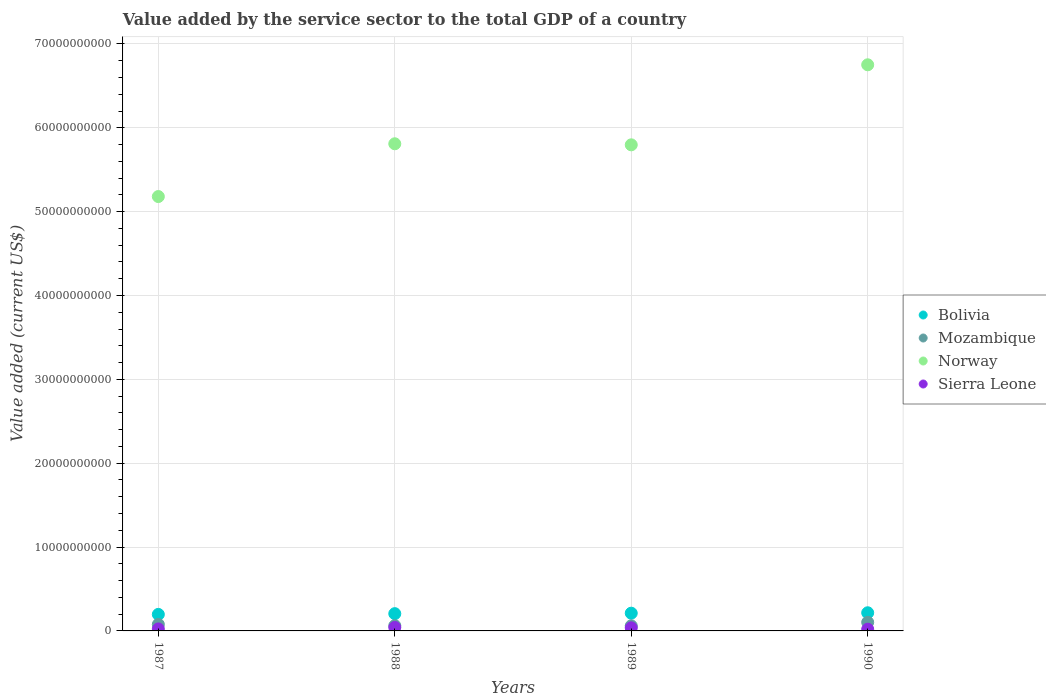Is the number of dotlines equal to the number of legend labels?
Make the answer very short. Yes. What is the value added by the service sector to the total GDP in Norway in 1989?
Make the answer very short. 5.80e+1. Across all years, what is the maximum value added by the service sector to the total GDP in Mozambique?
Your answer should be compact. 1.03e+09. Across all years, what is the minimum value added by the service sector to the total GDP in Sierra Leone?
Make the answer very short. 2.07e+08. What is the total value added by the service sector to the total GDP in Norway in the graph?
Make the answer very short. 2.35e+11. What is the difference between the value added by the service sector to the total GDP in Mozambique in 1987 and that in 1988?
Provide a short and direct response. 1.50e+08. What is the difference between the value added by the service sector to the total GDP in Mozambique in 1989 and the value added by the service sector to the total GDP in Norway in 1990?
Your response must be concise. -6.69e+1. What is the average value added by the service sector to the total GDP in Sierra Leone per year?
Your answer should be compact. 3.08e+08. In the year 1988, what is the difference between the value added by the service sector to the total GDP in Mozambique and value added by the service sector to the total GDP in Bolivia?
Your response must be concise. -1.43e+09. What is the ratio of the value added by the service sector to the total GDP in Sierra Leone in 1987 to that in 1989?
Your answer should be compact. 0.64. Is the value added by the service sector to the total GDP in Norway in 1987 less than that in 1989?
Make the answer very short. Yes. Is the difference between the value added by the service sector to the total GDP in Mozambique in 1987 and 1989 greater than the difference between the value added by the service sector to the total GDP in Bolivia in 1987 and 1989?
Make the answer very short. Yes. What is the difference between the highest and the second highest value added by the service sector to the total GDP in Bolivia?
Provide a short and direct response. 4.98e+07. What is the difference between the highest and the lowest value added by the service sector to the total GDP in Bolivia?
Your response must be concise. 1.94e+08. In how many years, is the value added by the service sector to the total GDP in Norway greater than the average value added by the service sector to the total GDP in Norway taken over all years?
Keep it short and to the point. 1. Is the sum of the value added by the service sector to the total GDP in Norway in 1987 and 1989 greater than the maximum value added by the service sector to the total GDP in Bolivia across all years?
Offer a very short reply. Yes. Is it the case that in every year, the sum of the value added by the service sector to the total GDP in Sierra Leone and value added by the service sector to the total GDP in Mozambique  is greater than the sum of value added by the service sector to the total GDP in Bolivia and value added by the service sector to the total GDP in Norway?
Give a very brief answer. No. Is it the case that in every year, the sum of the value added by the service sector to the total GDP in Bolivia and value added by the service sector to the total GDP in Mozambique  is greater than the value added by the service sector to the total GDP in Sierra Leone?
Provide a short and direct response. Yes. Is the value added by the service sector to the total GDP in Sierra Leone strictly greater than the value added by the service sector to the total GDP in Bolivia over the years?
Provide a short and direct response. No. How many dotlines are there?
Your answer should be very brief. 4. How many years are there in the graph?
Provide a succinct answer. 4. What is the difference between two consecutive major ticks on the Y-axis?
Make the answer very short. 1.00e+1. Are the values on the major ticks of Y-axis written in scientific E-notation?
Keep it short and to the point. No. Does the graph contain any zero values?
Provide a short and direct response. No. Where does the legend appear in the graph?
Provide a succinct answer. Center right. How many legend labels are there?
Give a very brief answer. 4. What is the title of the graph?
Your response must be concise. Value added by the service sector to the total GDP of a country. What is the label or title of the Y-axis?
Provide a succinct answer. Value added (current US$). What is the Value added (current US$) of Bolivia in 1987?
Ensure brevity in your answer.  1.97e+09. What is the Value added (current US$) in Mozambique in 1987?
Ensure brevity in your answer.  7.77e+08. What is the Value added (current US$) of Norway in 1987?
Provide a short and direct response. 5.18e+1. What is the Value added (current US$) of Sierra Leone in 1987?
Your answer should be very brief. 2.38e+08. What is the Value added (current US$) in Bolivia in 1988?
Give a very brief answer. 2.06e+09. What is the Value added (current US$) of Mozambique in 1988?
Offer a very short reply. 6.27e+08. What is the Value added (current US$) in Norway in 1988?
Make the answer very short. 5.81e+1. What is the Value added (current US$) in Sierra Leone in 1988?
Keep it short and to the point. 4.17e+08. What is the Value added (current US$) of Bolivia in 1989?
Provide a succinct answer. 2.12e+09. What is the Value added (current US$) in Mozambique in 1989?
Ensure brevity in your answer.  6.05e+08. What is the Value added (current US$) in Norway in 1989?
Offer a very short reply. 5.80e+1. What is the Value added (current US$) of Sierra Leone in 1989?
Ensure brevity in your answer.  3.71e+08. What is the Value added (current US$) of Bolivia in 1990?
Your response must be concise. 2.16e+09. What is the Value added (current US$) of Mozambique in 1990?
Provide a succinct answer. 1.03e+09. What is the Value added (current US$) in Norway in 1990?
Offer a terse response. 6.75e+1. What is the Value added (current US$) of Sierra Leone in 1990?
Your answer should be very brief. 2.07e+08. Across all years, what is the maximum Value added (current US$) in Bolivia?
Provide a succinct answer. 2.16e+09. Across all years, what is the maximum Value added (current US$) of Mozambique?
Offer a very short reply. 1.03e+09. Across all years, what is the maximum Value added (current US$) in Norway?
Your answer should be compact. 6.75e+1. Across all years, what is the maximum Value added (current US$) in Sierra Leone?
Offer a very short reply. 4.17e+08. Across all years, what is the minimum Value added (current US$) in Bolivia?
Provide a short and direct response. 1.97e+09. Across all years, what is the minimum Value added (current US$) of Mozambique?
Ensure brevity in your answer.  6.05e+08. Across all years, what is the minimum Value added (current US$) in Norway?
Keep it short and to the point. 5.18e+1. Across all years, what is the minimum Value added (current US$) of Sierra Leone?
Your answer should be compact. 2.07e+08. What is the total Value added (current US$) of Bolivia in the graph?
Your answer should be very brief. 8.31e+09. What is the total Value added (current US$) in Mozambique in the graph?
Keep it short and to the point. 3.03e+09. What is the total Value added (current US$) of Norway in the graph?
Ensure brevity in your answer.  2.35e+11. What is the total Value added (current US$) in Sierra Leone in the graph?
Make the answer very short. 1.23e+09. What is the difference between the Value added (current US$) in Bolivia in 1987 and that in 1988?
Give a very brief answer. -8.81e+07. What is the difference between the Value added (current US$) in Mozambique in 1987 and that in 1988?
Offer a terse response. 1.50e+08. What is the difference between the Value added (current US$) in Norway in 1987 and that in 1988?
Provide a short and direct response. -6.29e+09. What is the difference between the Value added (current US$) in Sierra Leone in 1987 and that in 1988?
Offer a very short reply. -1.79e+08. What is the difference between the Value added (current US$) in Bolivia in 1987 and that in 1989?
Make the answer very short. -1.44e+08. What is the difference between the Value added (current US$) of Mozambique in 1987 and that in 1989?
Ensure brevity in your answer.  1.72e+08. What is the difference between the Value added (current US$) in Norway in 1987 and that in 1989?
Provide a short and direct response. -6.17e+09. What is the difference between the Value added (current US$) in Sierra Leone in 1987 and that in 1989?
Offer a terse response. -1.32e+08. What is the difference between the Value added (current US$) of Bolivia in 1987 and that in 1990?
Ensure brevity in your answer.  -1.94e+08. What is the difference between the Value added (current US$) of Mozambique in 1987 and that in 1990?
Offer a terse response. -2.50e+08. What is the difference between the Value added (current US$) in Norway in 1987 and that in 1990?
Offer a very short reply. -1.57e+1. What is the difference between the Value added (current US$) in Sierra Leone in 1987 and that in 1990?
Offer a terse response. 3.17e+07. What is the difference between the Value added (current US$) of Bolivia in 1988 and that in 1989?
Offer a very short reply. -5.59e+07. What is the difference between the Value added (current US$) in Mozambique in 1988 and that in 1989?
Keep it short and to the point. 2.19e+07. What is the difference between the Value added (current US$) of Norway in 1988 and that in 1989?
Your response must be concise. 1.26e+08. What is the difference between the Value added (current US$) of Sierra Leone in 1988 and that in 1989?
Your answer should be compact. 4.65e+07. What is the difference between the Value added (current US$) in Bolivia in 1988 and that in 1990?
Your answer should be compact. -1.06e+08. What is the difference between the Value added (current US$) of Mozambique in 1988 and that in 1990?
Give a very brief answer. -4.00e+08. What is the difference between the Value added (current US$) of Norway in 1988 and that in 1990?
Provide a short and direct response. -9.42e+09. What is the difference between the Value added (current US$) in Sierra Leone in 1988 and that in 1990?
Provide a short and direct response. 2.11e+08. What is the difference between the Value added (current US$) of Bolivia in 1989 and that in 1990?
Provide a succinct answer. -4.98e+07. What is the difference between the Value added (current US$) of Mozambique in 1989 and that in 1990?
Provide a short and direct response. -4.22e+08. What is the difference between the Value added (current US$) in Norway in 1989 and that in 1990?
Provide a short and direct response. -9.54e+09. What is the difference between the Value added (current US$) of Sierra Leone in 1989 and that in 1990?
Make the answer very short. 1.64e+08. What is the difference between the Value added (current US$) of Bolivia in 1987 and the Value added (current US$) of Mozambique in 1988?
Your response must be concise. 1.34e+09. What is the difference between the Value added (current US$) of Bolivia in 1987 and the Value added (current US$) of Norway in 1988?
Provide a short and direct response. -5.61e+1. What is the difference between the Value added (current US$) of Bolivia in 1987 and the Value added (current US$) of Sierra Leone in 1988?
Offer a terse response. 1.55e+09. What is the difference between the Value added (current US$) in Mozambique in 1987 and the Value added (current US$) in Norway in 1988?
Offer a very short reply. -5.73e+1. What is the difference between the Value added (current US$) of Mozambique in 1987 and the Value added (current US$) of Sierra Leone in 1988?
Offer a very short reply. 3.59e+08. What is the difference between the Value added (current US$) of Norway in 1987 and the Value added (current US$) of Sierra Leone in 1988?
Give a very brief answer. 5.14e+1. What is the difference between the Value added (current US$) of Bolivia in 1987 and the Value added (current US$) of Mozambique in 1989?
Offer a terse response. 1.37e+09. What is the difference between the Value added (current US$) of Bolivia in 1987 and the Value added (current US$) of Norway in 1989?
Offer a very short reply. -5.60e+1. What is the difference between the Value added (current US$) in Bolivia in 1987 and the Value added (current US$) in Sierra Leone in 1989?
Offer a very short reply. 1.60e+09. What is the difference between the Value added (current US$) in Mozambique in 1987 and the Value added (current US$) in Norway in 1989?
Your response must be concise. -5.72e+1. What is the difference between the Value added (current US$) of Mozambique in 1987 and the Value added (current US$) of Sierra Leone in 1989?
Give a very brief answer. 4.06e+08. What is the difference between the Value added (current US$) in Norway in 1987 and the Value added (current US$) in Sierra Leone in 1989?
Your answer should be compact. 5.14e+1. What is the difference between the Value added (current US$) of Bolivia in 1987 and the Value added (current US$) of Mozambique in 1990?
Offer a very short reply. 9.45e+08. What is the difference between the Value added (current US$) in Bolivia in 1987 and the Value added (current US$) in Norway in 1990?
Keep it short and to the point. -6.55e+1. What is the difference between the Value added (current US$) in Bolivia in 1987 and the Value added (current US$) in Sierra Leone in 1990?
Your response must be concise. 1.76e+09. What is the difference between the Value added (current US$) of Mozambique in 1987 and the Value added (current US$) of Norway in 1990?
Give a very brief answer. -6.67e+1. What is the difference between the Value added (current US$) of Mozambique in 1987 and the Value added (current US$) of Sierra Leone in 1990?
Your response must be concise. 5.70e+08. What is the difference between the Value added (current US$) of Norway in 1987 and the Value added (current US$) of Sierra Leone in 1990?
Your answer should be very brief. 5.16e+1. What is the difference between the Value added (current US$) in Bolivia in 1988 and the Value added (current US$) in Mozambique in 1989?
Give a very brief answer. 1.45e+09. What is the difference between the Value added (current US$) of Bolivia in 1988 and the Value added (current US$) of Norway in 1989?
Give a very brief answer. -5.59e+1. What is the difference between the Value added (current US$) in Bolivia in 1988 and the Value added (current US$) in Sierra Leone in 1989?
Provide a succinct answer. 1.69e+09. What is the difference between the Value added (current US$) of Mozambique in 1988 and the Value added (current US$) of Norway in 1989?
Keep it short and to the point. -5.73e+1. What is the difference between the Value added (current US$) in Mozambique in 1988 and the Value added (current US$) in Sierra Leone in 1989?
Your response must be concise. 2.56e+08. What is the difference between the Value added (current US$) of Norway in 1988 and the Value added (current US$) of Sierra Leone in 1989?
Your response must be concise. 5.77e+1. What is the difference between the Value added (current US$) of Bolivia in 1988 and the Value added (current US$) of Mozambique in 1990?
Offer a very short reply. 1.03e+09. What is the difference between the Value added (current US$) of Bolivia in 1988 and the Value added (current US$) of Norway in 1990?
Provide a short and direct response. -6.55e+1. What is the difference between the Value added (current US$) in Bolivia in 1988 and the Value added (current US$) in Sierra Leone in 1990?
Give a very brief answer. 1.85e+09. What is the difference between the Value added (current US$) of Mozambique in 1988 and the Value added (current US$) of Norway in 1990?
Make the answer very short. -6.69e+1. What is the difference between the Value added (current US$) of Mozambique in 1988 and the Value added (current US$) of Sierra Leone in 1990?
Offer a terse response. 4.20e+08. What is the difference between the Value added (current US$) of Norway in 1988 and the Value added (current US$) of Sierra Leone in 1990?
Provide a short and direct response. 5.79e+1. What is the difference between the Value added (current US$) in Bolivia in 1989 and the Value added (current US$) in Mozambique in 1990?
Provide a short and direct response. 1.09e+09. What is the difference between the Value added (current US$) in Bolivia in 1989 and the Value added (current US$) in Norway in 1990?
Your answer should be very brief. -6.54e+1. What is the difference between the Value added (current US$) in Bolivia in 1989 and the Value added (current US$) in Sierra Leone in 1990?
Offer a very short reply. 1.91e+09. What is the difference between the Value added (current US$) of Mozambique in 1989 and the Value added (current US$) of Norway in 1990?
Offer a terse response. -6.69e+1. What is the difference between the Value added (current US$) in Mozambique in 1989 and the Value added (current US$) in Sierra Leone in 1990?
Provide a short and direct response. 3.98e+08. What is the difference between the Value added (current US$) of Norway in 1989 and the Value added (current US$) of Sierra Leone in 1990?
Your response must be concise. 5.78e+1. What is the average Value added (current US$) in Bolivia per year?
Give a very brief answer. 2.08e+09. What is the average Value added (current US$) of Mozambique per year?
Your answer should be compact. 7.59e+08. What is the average Value added (current US$) of Norway per year?
Offer a terse response. 5.88e+1. What is the average Value added (current US$) of Sierra Leone per year?
Provide a succinct answer. 3.08e+08. In the year 1987, what is the difference between the Value added (current US$) of Bolivia and Value added (current US$) of Mozambique?
Keep it short and to the point. 1.19e+09. In the year 1987, what is the difference between the Value added (current US$) in Bolivia and Value added (current US$) in Norway?
Provide a succinct answer. -4.98e+1. In the year 1987, what is the difference between the Value added (current US$) in Bolivia and Value added (current US$) in Sierra Leone?
Your answer should be compact. 1.73e+09. In the year 1987, what is the difference between the Value added (current US$) of Mozambique and Value added (current US$) of Norway?
Keep it short and to the point. -5.10e+1. In the year 1987, what is the difference between the Value added (current US$) in Mozambique and Value added (current US$) in Sierra Leone?
Ensure brevity in your answer.  5.38e+08. In the year 1987, what is the difference between the Value added (current US$) in Norway and Value added (current US$) in Sierra Leone?
Ensure brevity in your answer.  5.16e+1. In the year 1988, what is the difference between the Value added (current US$) of Bolivia and Value added (current US$) of Mozambique?
Provide a short and direct response. 1.43e+09. In the year 1988, what is the difference between the Value added (current US$) in Bolivia and Value added (current US$) in Norway?
Offer a very short reply. -5.60e+1. In the year 1988, what is the difference between the Value added (current US$) of Bolivia and Value added (current US$) of Sierra Leone?
Provide a succinct answer. 1.64e+09. In the year 1988, what is the difference between the Value added (current US$) of Mozambique and Value added (current US$) of Norway?
Offer a very short reply. -5.75e+1. In the year 1988, what is the difference between the Value added (current US$) in Mozambique and Value added (current US$) in Sierra Leone?
Your answer should be very brief. 2.09e+08. In the year 1988, what is the difference between the Value added (current US$) of Norway and Value added (current US$) of Sierra Leone?
Ensure brevity in your answer.  5.77e+1. In the year 1989, what is the difference between the Value added (current US$) in Bolivia and Value added (current US$) in Mozambique?
Offer a terse response. 1.51e+09. In the year 1989, what is the difference between the Value added (current US$) in Bolivia and Value added (current US$) in Norway?
Your response must be concise. -5.59e+1. In the year 1989, what is the difference between the Value added (current US$) of Bolivia and Value added (current US$) of Sierra Leone?
Ensure brevity in your answer.  1.74e+09. In the year 1989, what is the difference between the Value added (current US$) in Mozambique and Value added (current US$) in Norway?
Offer a very short reply. -5.74e+1. In the year 1989, what is the difference between the Value added (current US$) in Mozambique and Value added (current US$) in Sierra Leone?
Provide a succinct answer. 2.34e+08. In the year 1989, what is the difference between the Value added (current US$) of Norway and Value added (current US$) of Sierra Leone?
Make the answer very short. 5.76e+1. In the year 1990, what is the difference between the Value added (current US$) in Bolivia and Value added (current US$) in Mozambique?
Keep it short and to the point. 1.14e+09. In the year 1990, what is the difference between the Value added (current US$) in Bolivia and Value added (current US$) in Norway?
Your answer should be very brief. -6.53e+1. In the year 1990, what is the difference between the Value added (current US$) of Bolivia and Value added (current US$) of Sierra Leone?
Keep it short and to the point. 1.96e+09. In the year 1990, what is the difference between the Value added (current US$) in Mozambique and Value added (current US$) in Norway?
Offer a terse response. -6.65e+1. In the year 1990, what is the difference between the Value added (current US$) of Mozambique and Value added (current US$) of Sierra Leone?
Your answer should be compact. 8.20e+08. In the year 1990, what is the difference between the Value added (current US$) in Norway and Value added (current US$) in Sierra Leone?
Your response must be concise. 6.73e+1. What is the ratio of the Value added (current US$) in Bolivia in 1987 to that in 1988?
Make the answer very short. 0.96. What is the ratio of the Value added (current US$) of Mozambique in 1987 to that in 1988?
Offer a very short reply. 1.24. What is the ratio of the Value added (current US$) of Norway in 1987 to that in 1988?
Your answer should be very brief. 0.89. What is the ratio of the Value added (current US$) in Sierra Leone in 1987 to that in 1988?
Provide a short and direct response. 0.57. What is the ratio of the Value added (current US$) in Bolivia in 1987 to that in 1989?
Offer a terse response. 0.93. What is the ratio of the Value added (current US$) of Mozambique in 1987 to that in 1989?
Make the answer very short. 1.28. What is the ratio of the Value added (current US$) of Norway in 1987 to that in 1989?
Your answer should be very brief. 0.89. What is the ratio of the Value added (current US$) in Sierra Leone in 1987 to that in 1989?
Offer a terse response. 0.64. What is the ratio of the Value added (current US$) of Bolivia in 1987 to that in 1990?
Your answer should be compact. 0.91. What is the ratio of the Value added (current US$) in Mozambique in 1987 to that in 1990?
Your response must be concise. 0.76. What is the ratio of the Value added (current US$) of Norway in 1987 to that in 1990?
Your answer should be very brief. 0.77. What is the ratio of the Value added (current US$) of Sierra Leone in 1987 to that in 1990?
Provide a short and direct response. 1.15. What is the ratio of the Value added (current US$) in Bolivia in 1988 to that in 1989?
Offer a very short reply. 0.97. What is the ratio of the Value added (current US$) in Mozambique in 1988 to that in 1989?
Your answer should be very brief. 1.04. What is the ratio of the Value added (current US$) of Norway in 1988 to that in 1989?
Make the answer very short. 1. What is the ratio of the Value added (current US$) of Sierra Leone in 1988 to that in 1989?
Your answer should be very brief. 1.13. What is the ratio of the Value added (current US$) in Bolivia in 1988 to that in 1990?
Offer a very short reply. 0.95. What is the ratio of the Value added (current US$) in Mozambique in 1988 to that in 1990?
Ensure brevity in your answer.  0.61. What is the ratio of the Value added (current US$) of Norway in 1988 to that in 1990?
Make the answer very short. 0.86. What is the ratio of the Value added (current US$) in Sierra Leone in 1988 to that in 1990?
Keep it short and to the point. 2.02. What is the ratio of the Value added (current US$) in Bolivia in 1989 to that in 1990?
Provide a short and direct response. 0.98. What is the ratio of the Value added (current US$) of Mozambique in 1989 to that in 1990?
Your answer should be compact. 0.59. What is the ratio of the Value added (current US$) in Norway in 1989 to that in 1990?
Make the answer very short. 0.86. What is the ratio of the Value added (current US$) in Sierra Leone in 1989 to that in 1990?
Offer a very short reply. 1.79. What is the difference between the highest and the second highest Value added (current US$) of Bolivia?
Your response must be concise. 4.98e+07. What is the difference between the highest and the second highest Value added (current US$) of Mozambique?
Keep it short and to the point. 2.50e+08. What is the difference between the highest and the second highest Value added (current US$) in Norway?
Provide a succinct answer. 9.42e+09. What is the difference between the highest and the second highest Value added (current US$) of Sierra Leone?
Make the answer very short. 4.65e+07. What is the difference between the highest and the lowest Value added (current US$) of Bolivia?
Provide a succinct answer. 1.94e+08. What is the difference between the highest and the lowest Value added (current US$) of Mozambique?
Offer a very short reply. 4.22e+08. What is the difference between the highest and the lowest Value added (current US$) of Norway?
Your response must be concise. 1.57e+1. What is the difference between the highest and the lowest Value added (current US$) in Sierra Leone?
Offer a terse response. 2.11e+08. 